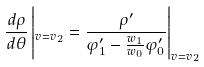Convert formula to latex. <formula><loc_0><loc_0><loc_500><loc_500>\frac { d \rho } { d \theta } \left | _ { v = v _ { 2 } } = \frac { \rho ^ { \prime } } { \varphi _ { 1 } ^ { \prime } - \frac { w _ { 1 } } { w _ { 0 } } \varphi _ { 0 } ^ { \prime } } \right | _ { v = v _ { 2 } }</formula> 